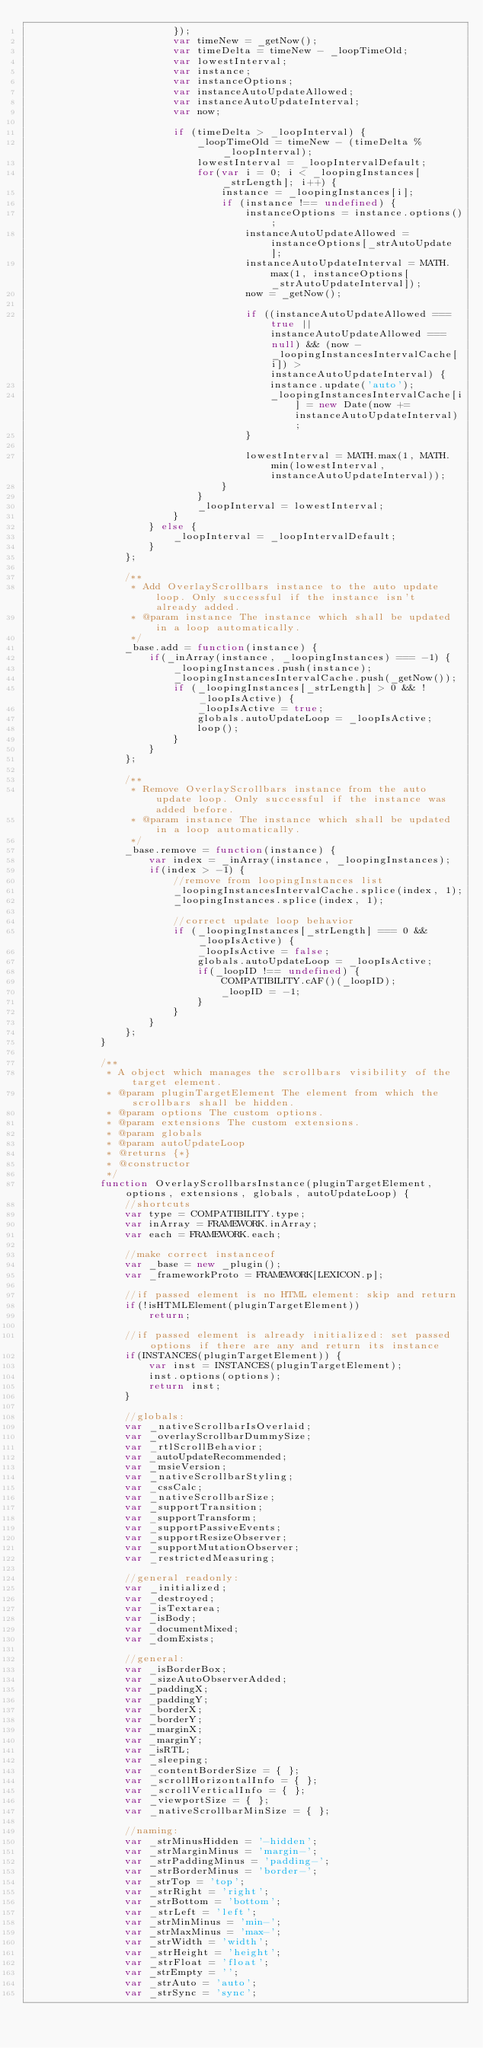<code> <loc_0><loc_0><loc_500><loc_500><_JavaScript_>                        });
                        var timeNew = _getNow();
                        var timeDelta = timeNew - _loopTimeOld;
                        var lowestInterval;
                        var instance;
                        var instanceOptions;
                        var instanceAutoUpdateAllowed;
                        var instanceAutoUpdateInterval;
                        var now;

                        if (timeDelta > _loopInterval) {
                            _loopTimeOld = timeNew - (timeDelta % _loopInterval);
                            lowestInterval = _loopIntervalDefault;
                            for(var i = 0; i < _loopingInstances[_strLength]; i++) {
                                instance = _loopingInstances[i];
                                if (instance !== undefined) {
                                    instanceOptions = instance.options();
                                    instanceAutoUpdateAllowed = instanceOptions[_strAutoUpdate];
                                    instanceAutoUpdateInterval = MATH.max(1, instanceOptions[_strAutoUpdateInterval]);
                                    now = _getNow();

                                    if ((instanceAutoUpdateAllowed === true || instanceAutoUpdateAllowed === null) && (now - _loopingInstancesIntervalCache[i]) > instanceAutoUpdateInterval) {
                                        instance.update('auto');
                                        _loopingInstancesIntervalCache[i] = new Date(now += instanceAutoUpdateInterval);
                                    }

                                    lowestInterval = MATH.max(1, MATH.min(lowestInterval, instanceAutoUpdateInterval));
                                }
                            }
                            _loopInterval = lowestInterval;
                        }
                    } else {
                        _loopInterval = _loopIntervalDefault;
                    }
                };

                /**
                 * Add OverlayScrollbars instance to the auto update loop. Only successful if the instance isn't already added.
                 * @param instance The instance which shall be updated in a loop automatically.
                 */
                _base.add = function(instance) {
                    if(_inArray(instance, _loopingInstances) === -1) {
                        _loopingInstances.push(instance);
                        _loopingInstancesIntervalCache.push(_getNow());
                        if (_loopingInstances[_strLength] > 0 && !_loopIsActive) {
                            _loopIsActive = true;
                            globals.autoUpdateLoop = _loopIsActive;
                            loop();
                        }
                    }
                };

                /**
                 * Remove OverlayScrollbars instance from the auto update loop. Only successful if the instance was added before.
                 * @param instance The instance which shall be updated in a loop automatically.
                 */
                _base.remove = function(instance) {
                    var index = _inArray(instance, _loopingInstances);
                    if(index > -1) {
                        //remove from loopingInstances list
                        _loopingInstancesIntervalCache.splice(index, 1);
                        _loopingInstances.splice(index, 1);

                        //correct update loop behavior
                        if (_loopingInstances[_strLength] === 0 && _loopIsActive) {
                            _loopIsActive = false;
                            globals.autoUpdateLoop = _loopIsActive;
                            if(_loopID !== undefined) {
                                COMPATIBILITY.cAF()(_loopID);
                                _loopID = -1;
                            }
                        }
                    }
                };
            }

            /**
             * A object which manages the scrollbars visibility of the target element.
             * @param pluginTargetElement The element from which the scrollbars shall be hidden.
             * @param options The custom options.
             * @param extensions The custom extensions.
             * @param globals
             * @param autoUpdateLoop
             * @returns {*}
             * @constructor
             */
            function OverlayScrollbarsInstance(pluginTargetElement, options, extensions, globals, autoUpdateLoop) {
                //shortcuts
                var type = COMPATIBILITY.type;
                var inArray = FRAMEWORK.inArray;
                var each = FRAMEWORK.each;
                
                //make correct instanceof
                var _base = new _plugin();
                var _frameworkProto = FRAMEWORK[LEXICON.p];
                
                //if passed element is no HTML element: skip and return
                if(!isHTMLElement(pluginTargetElement))
                    return;
                
                //if passed element is already initialized: set passed options if there are any and return its instance
                if(INSTANCES(pluginTargetElement)) {
                    var inst = INSTANCES(pluginTargetElement);
                    inst.options(options);
                    return inst;
                }

                //globals:
                var _nativeScrollbarIsOverlaid;
                var _overlayScrollbarDummySize;
                var _rtlScrollBehavior;
                var _autoUpdateRecommended;
                var _msieVersion;
                var _nativeScrollbarStyling;
                var _cssCalc;
                var _nativeScrollbarSize;
                var _supportTransition;
                var _supportTransform;
                var _supportPassiveEvents;
                var _supportResizeObserver;
                var _supportMutationObserver;
                var _restrictedMeasuring;

                //general readonly:
                var _initialized;
                var _destroyed;
                var _isTextarea;
                var _isBody;
                var _documentMixed;
                var _domExists;

                //general:
                var _isBorderBox;
                var _sizeAutoObserverAdded;
                var _paddingX;
                var _paddingY;
                var _borderX;
                var _borderY;
                var _marginX;
                var _marginY;
                var _isRTL;
                var _sleeping;
                var _contentBorderSize = { };
                var _scrollHorizontalInfo = { };
                var _scrollVerticalInfo = { };
                var _viewportSize = { };
                var _nativeScrollbarMinSize = { };

                //naming:
                var _strMinusHidden = '-hidden';
                var _strMarginMinus = 'margin-';
                var _strPaddingMinus = 'padding-';
                var _strBorderMinus = 'border-';
                var _strTop = 'top';
                var _strRight = 'right';
                var _strBottom = 'bottom';
                var _strLeft = 'left';
                var _strMinMinus = 'min-';
                var _strMaxMinus = 'max-';
                var _strWidth = 'width';
                var _strHeight = 'height';
                var _strFloat = 'float';
                var _strEmpty = '';
                var _strAuto = 'auto';
                var _strSync = 'sync';</code> 